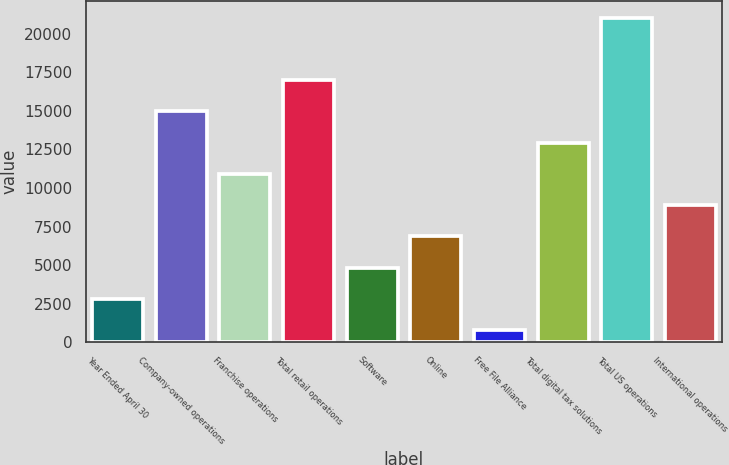<chart> <loc_0><loc_0><loc_500><loc_500><bar_chart><fcel>Year Ended April 30<fcel>Company-owned operations<fcel>Franchise operations<fcel>Total retail operations<fcel>Software<fcel>Online<fcel>Free File Alliance<fcel>Total digital tax solutions<fcel>Total US operations<fcel>International operations<nl><fcel>2813.1<fcel>14963.7<fcel>10913.5<fcel>16988.8<fcel>4838.2<fcel>6863.3<fcel>788<fcel>12938.6<fcel>21039<fcel>8888.4<nl></chart> 